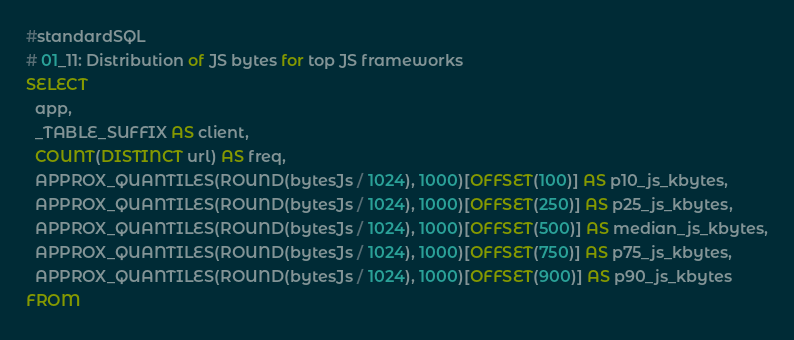Convert code to text. <code><loc_0><loc_0><loc_500><loc_500><_SQL_>#standardSQL
# 01_11: Distribution of JS bytes for top JS frameworks
SELECT
  app,
  _TABLE_SUFFIX AS client,
  COUNT(DISTINCT url) AS freq,
  APPROX_QUANTILES(ROUND(bytesJs / 1024), 1000)[OFFSET(100)] AS p10_js_kbytes,
  APPROX_QUANTILES(ROUND(bytesJs / 1024), 1000)[OFFSET(250)] AS p25_js_kbytes,
  APPROX_QUANTILES(ROUND(bytesJs / 1024), 1000)[OFFSET(500)] AS median_js_kbytes,
  APPROX_QUANTILES(ROUND(bytesJs / 1024), 1000)[OFFSET(750)] AS p75_js_kbytes,
  APPROX_QUANTILES(ROUND(bytesJs / 1024), 1000)[OFFSET(900)] AS p90_js_kbytes
FROM</code> 